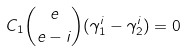Convert formula to latex. <formula><loc_0><loc_0><loc_500><loc_500>C _ { 1 } { e \choose { e - i } } ( \gamma _ { 1 } ^ { i } - \gamma _ { 2 } ^ { i } ) = 0</formula> 